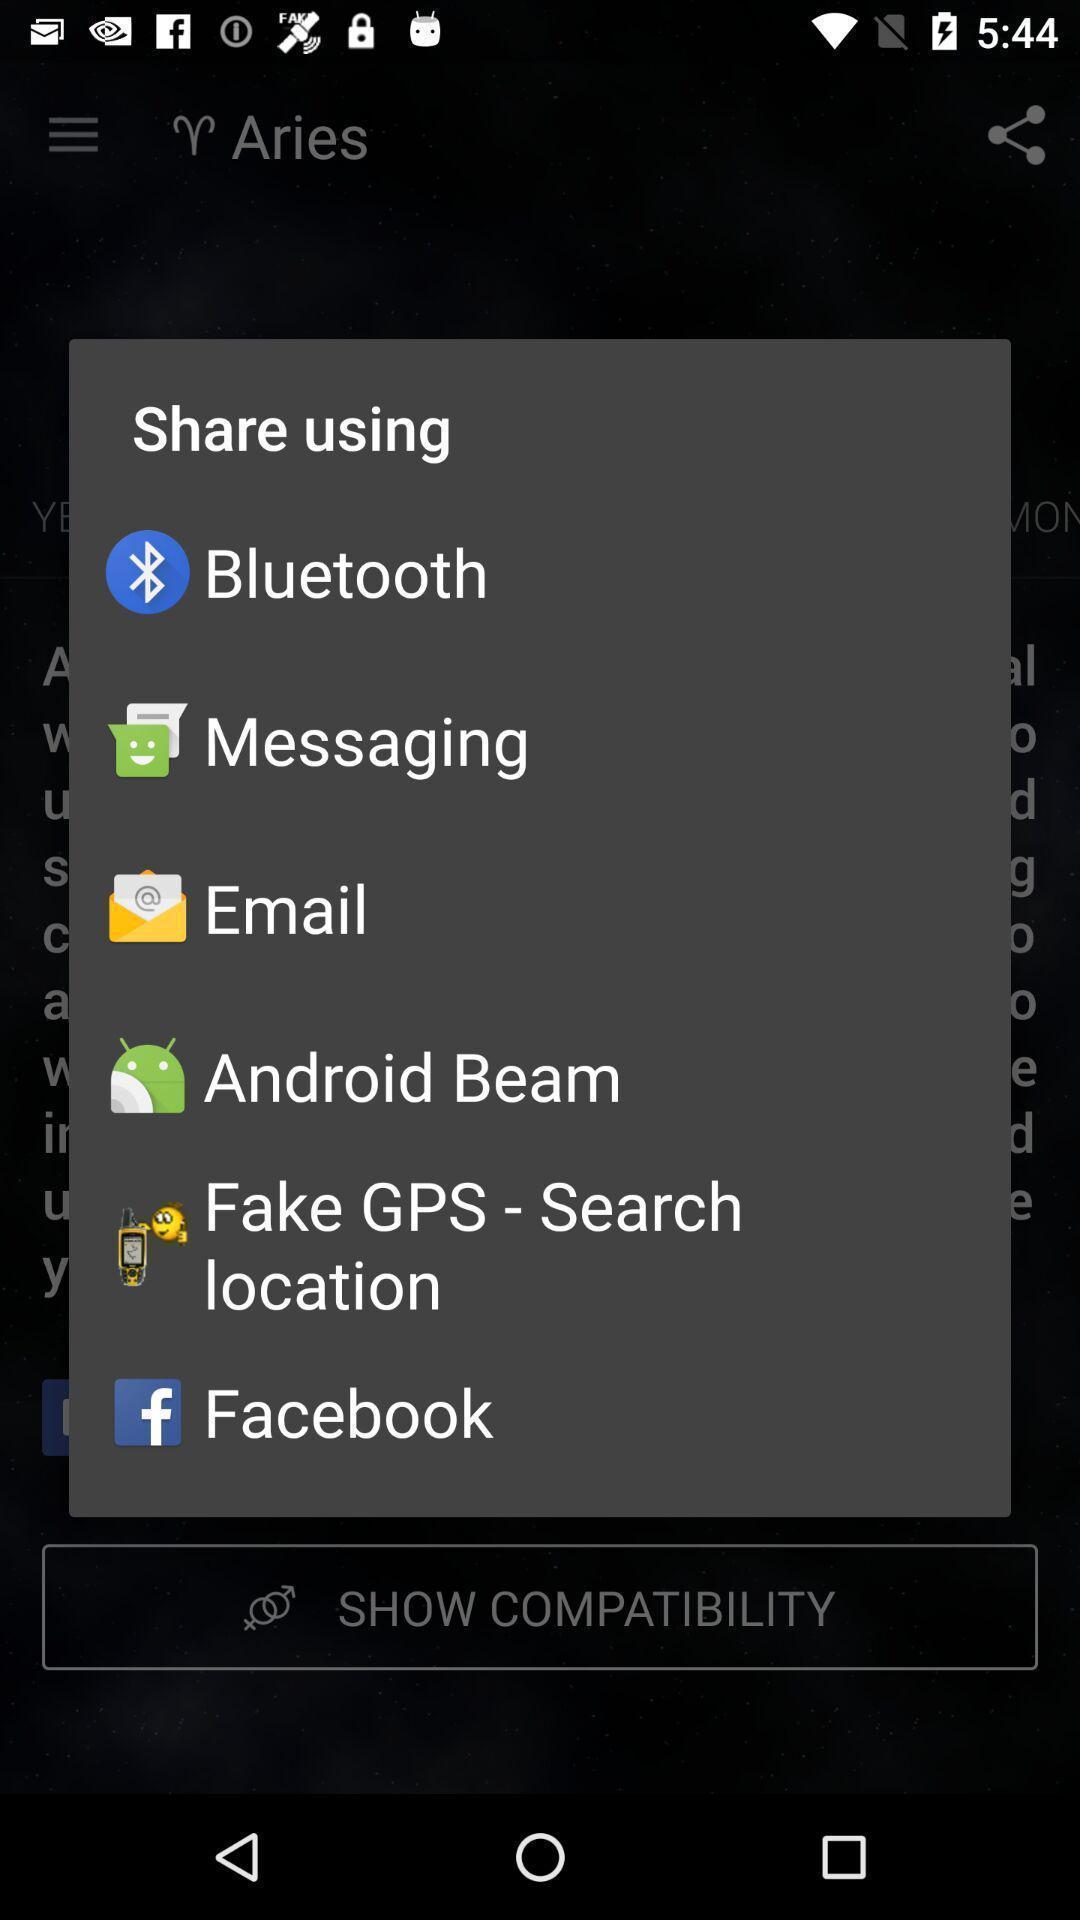Explain the elements present in this screenshot. Popup showing different apps to share. 